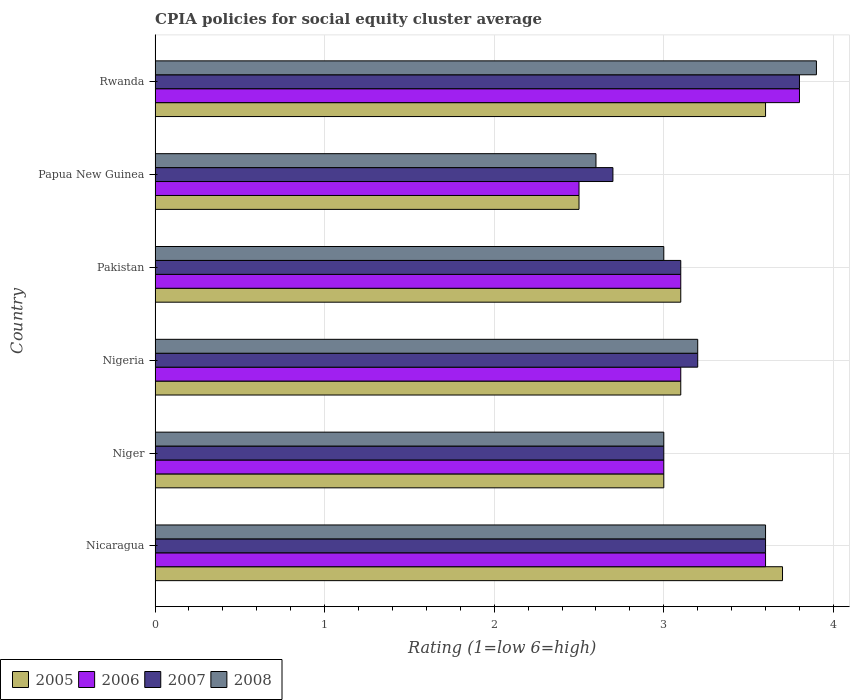How many groups of bars are there?
Your answer should be compact. 6. Are the number of bars on each tick of the Y-axis equal?
Give a very brief answer. Yes. What is the label of the 5th group of bars from the top?
Keep it short and to the point. Niger. Across all countries, what is the maximum CPIA rating in 2007?
Give a very brief answer. 3.8. In which country was the CPIA rating in 2007 maximum?
Keep it short and to the point. Rwanda. In which country was the CPIA rating in 2008 minimum?
Offer a very short reply. Papua New Guinea. What is the total CPIA rating in 2005 in the graph?
Provide a succinct answer. 19. What is the difference between the CPIA rating in 2008 in Niger and that in Pakistan?
Provide a succinct answer. 0. What is the difference between the CPIA rating in 2008 in Nigeria and the CPIA rating in 2007 in Nicaragua?
Your answer should be compact. -0.4. What is the average CPIA rating in 2006 per country?
Your response must be concise. 3.18. What is the difference between the CPIA rating in 2006 and CPIA rating in 2008 in Nicaragua?
Provide a short and direct response. 0. In how many countries, is the CPIA rating in 2008 greater than 2.2 ?
Your answer should be compact. 6. Is the difference between the CPIA rating in 2006 in Niger and Pakistan greater than the difference between the CPIA rating in 2008 in Niger and Pakistan?
Your answer should be compact. No. What is the difference between the highest and the second highest CPIA rating in 2005?
Keep it short and to the point. 0.1. What is the difference between the highest and the lowest CPIA rating in 2006?
Provide a succinct answer. 1.3. Are all the bars in the graph horizontal?
Keep it short and to the point. Yes. What is the difference between two consecutive major ticks on the X-axis?
Offer a very short reply. 1. Are the values on the major ticks of X-axis written in scientific E-notation?
Give a very brief answer. No. Does the graph contain grids?
Ensure brevity in your answer.  Yes. Where does the legend appear in the graph?
Your answer should be compact. Bottom left. How many legend labels are there?
Keep it short and to the point. 4. What is the title of the graph?
Your answer should be compact. CPIA policies for social equity cluster average. What is the label or title of the X-axis?
Your response must be concise. Rating (1=low 6=high). What is the Rating (1=low 6=high) in 2006 in Nicaragua?
Provide a succinct answer. 3.6. What is the Rating (1=low 6=high) in 2007 in Nicaragua?
Provide a succinct answer. 3.6. What is the Rating (1=low 6=high) of 2006 in Nigeria?
Keep it short and to the point. 3.1. What is the Rating (1=low 6=high) in 2008 in Nigeria?
Your answer should be very brief. 3.2. What is the Rating (1=low 6=high) of 2005 in Pakistan?
Provide a short and direct response. 3.1. What is the Rating (1=low 6=high) in 2008 in Pakistan?
Your answer should be compact. 3. What is the Rating (1=low 6=high) of 2006 in Papua New Guinea?
Your answer should be very brief. 2.5. What is the Rating (1=low 6=high) of 2006 in Rwanda?
Offer a very short reply. 3.8. Across all countries, what is the maximum Rating (1=low 6=high) in 2005?
Your response must be concise. 3.7. Across all countries, what is the minimum Rating (1=low 6=high) in 2006?
Your answer should be compact. 2.5. Across all countries, what is the minimum Rating (1=low 6=high) in 2008?
Offer a terse response. 2.6. What is the total Rating (1=low 6=high) in 2007 in the graph?
Your answer should be very brief. 19.4. What is the total Rating (1=low 6=high) of 2008 in the graph?
Provide a succinct answer. 19.3. What is the difference between the Rating (1=low 6=high) of 2007 in Nicaragua and that in Niger?
Offer a very short reply. 0.6. What is the difference between the Rating (1=low 6=high) of 2008 in Nicaragua and that in Niger?
Provide a succinct answer. 0.6. What is the difference between the Rating (1=low 6=high) of 2005 in Nicaragua and that in Nigeria?
Your answer should be very brief. 0.6. What is the difference between the Rating (1=low 6=high) of 2006 in Nicaragua and that in Nigeria?
Keep it short and to the point. 0.5. What is the difference between the Rating (1=low 6=high) in 2007 in Nicaragua and that in Nigeria?
Provide a succinct answer. 0.4. What is the difference between the Rating (1=low 6=high) in 2005 in Nicaragua and that in Pakistan?
Give a very brief answer. 0.6. What is the difference between the Rating (1=low 6=high) of 2007 in Nicaragua and that in Papua New Guinea?
Your answer should be very brief. 0.9. What is the difference between the Rating (1=low 6=high) in 2008 in Nicaragua and that in Papua New Guinea?
Your answer should be very brief. 1. What is the difference between the Rating (1=low 6=high) of 2006 in Nicaragua and that in Rwanda?
Your response must be concise. -0.2. What is the difference between the Rating (1=low 6=high) in 2005 in Niger and that in Nigeria?
Ensure brevity in your answer.  -0.1. What is the difference between the Rating (1=low 6=high) of 2006 in Niger and that in Nigeria?
Keep it short and to the point. -0.1. What is the difference between the Rating (1=low 6=high) in 2007 in Niger and that in Nigeria?
Provide a short and direct response. -0.2. What is the difference between the Rating (1=low 6=high) in 2008 in Niger and that in Nigeria?
Provide a succinct answer. -0.2. What is the difference between the Rating (1=low 6=high) in 2005 in Niger and that in Pakistan?
Ensure brevity in your answer.  -0.1. What is the difference between the Rating (1=low 6=high) of 2006 in Niger and that in Pakistan?
Offer a very short reply. -0.1. What is the difference between the Rating (1=low 6=high) of 2007 in Niger and that in Pakistan?
Provide a succinct answer. -0.1. What is the difference between the Rating (1=low 6=high) of 2005 in Niger and that in Papua New Guinea?
Make the answer very short. 0.5. What is the difference between the Rating (1=low 6=high) in 2005 in Niger and that in Rwanda?
Ensure brevity in your answer.  -0.6. What is the difference between the Rating (1=low 6=high) of 2006 in Niger and that in Rwanda?
Your answer should be compact. -0.8. What is the difference between the Rating (1=low 6=high) of 2008 in Niger and that in Rwanda?
Provide a short and direct response. -0.9. What is the difference between the Rating (1=low 6=high) in 2006 in Nigeria and that in Pakistan?
Ensure brevity in your answer.  0. What is the difference between the Rating (1=low 6=high) in 2007 in Nigeria and that in Papua New Guinea?
Ensure brevity in your answer.  0.5. What is the difference between the Rating (1=low 6=high) in 2007 in Nigeria and that in Rwanda?
Give a very brief answer. -0.6. What is the difference between the Rating (1=low 6=high) of 2006 in Pakistan and that in Papua New Guinea?
Your answer should be very brief. 0.6. What is the difference between the Rating (1=low 6=high) in 2007 in Pakistan and that in Papua New Guinea?
Give a very brief answer. 0.4. What is the difference between the Rating (1=low 6=high) of 2008 in Pakistan and that in Papua New Guinea?
Offer a very short reply. 0.4. What is the difference between the Rating (1=low 6=high) in 2005 in Pakistan and that in Rwanda?
Offer a terse response. -0.5. What is the difference between the Rating (1=low 6=high) of 2007 in Pakistan and that in Rwanda?
Your answer should be compact. -0.7. What is the difference between the Rating (1=low 6=high) in 2008 in Pakistan and that in Rwanda?
Give a very brief answer. -0.9. What is the difference between the Rating (1=low 6=high) in 2007 in Papua New Guinea and that in Rwanda?
Your response must be concise. -1.1. What is the difference between the Rating (1=low 6=high) of 2008 in Papua New Guinea and that in Rwanda?
Your response must be concise. -1.3. What is the difference between the Rating (1=low 6=high) of 2005 in Nicaragua and the Rating (1=low 6=high) of 2007 in Niger?
Offer a very short reply. 0.7. What is the difference between the Rating (1=low 6=high) of 2007 in Nicaragua and the Rating (1=low 6=high) of 2008 in Niger?
Provide a succinct answer. 0.6. What is the difference between the Rating (1=low 6=high) of 2005 in Nicaragua and the Rating (1=low 6=high) of 2006 in Nigeria?
Keep it short and to the point. 0.6. What is the difference between the Rating (1=low 6=high) in 2005 in Nicaragua and the Rating (1=low 6=high) in 2008 in Nigeria?
Give a very brief answer. 0.5. What is the difference between the Rating (1=low 6=high) of 2006 in Nicaragua and the Rating (1=low 6=high) of 2008 in Nigeria?
Offer a very short reply. 0.4. What is the difference between the Rating (1=low 6=high) of 2007 in Nicaragua and the Rating (1=low 6=high) of 2008 in Pakistan?
Provide a succinct answer. 0.6. What is the difference between the Rating (1=low 6=high) in 2005 in Nicaragua and the Rating (1=low 6=high) in 2007 in Papua New Guinea?
Your answer should be compact. 1. What is the difference between the Rating (1=low 6=high) in 2006 in Nicaragua and the Rating (1=low 6=high) in 2007 in Papua New Guinea?
Offer a very short reply. 0.9. What is the difference between the Rating (1=low 6=high) of 2006 in Nicaragua and the Rating (1=low 6=high) of 2008 in Papua New Guinea?
Provide a succinct answer. 1. What is the difference between the Rating (1=low 6=high) of 2007 in Nicaragua and the Rating (1=low 6=high) of 2008 in Papua New Guinea?
Provide a short and direct response. 1. What is the difference between the Rating (1=low 6=high) in 2006 in Nicaragua and the Rating (1=low 6=high) in 2007 in Rwanda?
Your answer should be very brief. -0.2. What is the difference between the Rating (1=low 6=high) of 2005 in Niger and the Rating (1=low 6=high) of 2006 in Nigeria?
Ensure brevity in your answer.  -0.1. What is the difference between the Rating (1=low 6=high) in 2005 in Niger and the Rating (1=low 6=high) in 2007 in Nigeria?
Make the answer very short. -0.2. What is the difference between the Rating (1=low 6=high) of 2005 in Niger and the Rating (1=low 6=high) of 2008 in Nigeria?
Give a very brief answer. -0.2. What is the difference between the Rating (1=low 6=high) in 2007 in Niger and the Rating (1=low 6=high) in 2008 in Nigeria?
Your answer should be compact. -0.2. What is the difference between the Rating (1=low 6=high) in 2006 in Niger and the Rating (1=low 6=high) in 2007 in Pakistan?
Offer a very short reply. -0.1. What is the difference between the Rating (1=low 6=high) in 2005 in Niger and the Rating (1=low 6=high) in 2006 in Papua New Guinea?
Your answer should be compact. 0.5. What is the difference between the Rating (1=low 6=high) in 2006 in Niger and the Rating (1=low 6=high) in 2007 in Papua New Guinea?
Your answer should be compact. 0.3. What is the difference between the Rating (1=low 6=high) in 2007 in Niger and the Rating (1=low 6=high) in 2008 in Papua New Guinea?
Provide a short and direct response. 0.4. What is the difference between the Rating (1=low 6=high) of 2005 in Niger and the Rating (1=low 6=high) of 2006 in Rwanda?
Your answer should be very brief. -0.8. What is the difference between the Rating (1=low 6=high) in 2005 in Niger and the Rating (1=low 6=high) in 2007 in Rwanda?
Offer a terse response. -0.8. What is the difference between the Rating (1=low 6=high) of 2005 in Niger and the Rating (1=low 6=high) of 2008 in Rwanda?
Provide a short and direct response. -0.9. What is the difference between the Rating (1=low 6=high) of 2007 in Niger and the Rating (1=low 6=high) of 2008 in Rwanda?
Your answer should be very brief. -0.9. What is the difference between the Rating (1=low 6=high) in 2007 in Nigeria and the Rating (1=low 6=high) in 2008 in Pakistan?
Ensure brevity in your answer.  0.2. What is the difference between the Rating (1=low 6=high) of 2005 in Nigeria and the Rating (1=low 6=high) of 2006 in Papua New Guinea?
Offer a terse response. 0.6. What is the difference between the Rating (1=low 6=high) of 2006 in Nigeria and the Rating (1=low 6=high) of 2008 in Papua New Guinea?
Your answer should be compact. 0.5. What is the difference between the Rating (1=low 6=high) of 2005 in Nigeria and the Rating (1=low 6=high) of 2006 in Rwanda?
Give a very brief answer. -0.7. What is the difference between the Rating (1=low 6=high) of 2005 in Nigeria and the Rating (1=low 6=high) of 2007 in Rwanda?
Keep it short and to the point. -0.7. What is the difference between the Rating (1=low 6=high) of 2005 in Nigeria and the Rating (1=low 6=high) of 2008 in Rwanda?
Your answer should be very brief. -0.8. What is the difference between the Rating (1=low 6=high) of 2005 in Pakistan and the Rating (1=low 6=high) of 2006 in Papua New Guinea?
Keep it short and to the point. 0.6. What is the difference between the Rating (1=low 6=high) of 2006 in Pakistan and the Rating (1=low 6=high) of 2007 in Papua New Guinea?
Provide a succinct answer. 0.4. What is the difference between the Rating (1=low 6=high) in 2006 in Pakistan and the Rating (1=low 6=high) in 2008 in Papua New Guinea?
Make the answer very short. 0.5. What is the difference between the Rating (1=low 6=high) of 2007 in Pakistan and the Rating (1=low 6=high) of 2008 in Papua New Guinea?
Provide a succinct answer. 0.5. What is the difference between the Rating (1=low 6=high) in 2005 in Pakistan and the Rating (1=low 6=high) in 2006 in Rwanda?
Ensure brevity in your answer.  -0.7. What is the difference between the Rating (1=low 6=high) of 2007 in Pakistan and the Rating (1=low 6=high) of 2008 in Rwanda?
Make the answer very short. -0.8. What is the difference between the Rating (1=low 6=high) in 2006 in Papua New Guinea and the Rating (1=low 6=high) in 2008 in Rwanda?
Keep it short and to the point. -1.4. What is the average Rating (1=low 6=high) of 2005 per country?
Ensure brevity in your answer.  3.17. What is the average Rating (1=low 6=high) in 2006 per country?
Your response must be concise. 3.18. What is the average Rating (1=low 6=high) of 2007 per country?
Keep it short and to the point. 3.23. What is the average Rating (1=low 6=high) in 2008 per country?
Your answer should be very brief. 3.22. What is the difference between the Rating (1=low 6=high) in 2005 and Rating (1=low 6=high) in 2007 in Nicaragua?
Your answer should be very brief. 0.1. What is the difference between the Rating (1=low 6=high) in 2005 and Rating (1=low 6=high) in 2008 in Nicaragua?
Ensure brevity in your answer.  0.1. What is the difference between the Rating (1=low 6=high) of 2006 and Rating (1=low 6=high) of 2007 in Nicaragua?
Offer a very short reply. 0. What is the difference between the Rating (1=low 6=high) of 2006 and Rating (1=low 6=high) of 2008 in Nicaragua?
Your answer should be very brief. 0. What is the difference between the Rating (1=low 6=high) of 2005 and Rating (1=low 6=high) of 2006 in Niger?
Provide a succinct answer. 0. What is the difference between the Rating (1=low 6=high) of 2005 and Rating (1=low 6=high) of 2007 in Niger?
Ensure brevity in your answer.  0. What is the difference between the Rating (1=low 6=high) in 2005 and Rating (1=low 6=high) in 2006 in Nigeria?
Give a very brief answer. 0. What is the difference between the Rating (1=low 6=high) in 2005 and Rating (1=low 6=high) in 2008 in Nigeria?
Keep it short and to the point. -0.1. What is the difference between the Rating (1=low 6=high) in 2006 and Rating (1=low 6=high) in 2007 in Nigeria?
Your answer should be very brief. -0.1. What is the difference between the Rating (1=low 6=high) in 2006 and Rating (1=low 6=high) in 2008 in Nigeria?
Your answer should be very brief. -0.1. What is the difference between the Rating (1=low 6=high) in 2007 and Rating (1=low 6=high) in 2008 in Nigeria?
Offer a very short reply. 0. What is the difference between the Rating (1=low 6=high) in 2005 and Rating (1=low 6=high) in 2006 in Pakistan?
Ensure brevity in your answer.  0. What is the difference between the Rating (1=low 6=high) of 2005 and Rating (1=low 6=high) of 2008 in Pakistan?
Your answer should be compact. 0.1. What is the difference between the Rating (1=low 6=high) in 2006 and Rating (1=low 6=high) in 2008 in Pakistan?
Keep it short and to the point. 0.1. What is the difference between the Rating (1=low 6=high) in 2007 and Rating (1=low 6=high) in 2008 in Papua New Guinea?
Your answer should be very brief. 0.1. What is the difference between the Rating (1=low 6=high) of 2005 and Rating (1=low 6=high) of 2007 in Rwanda?
Provide a short and direct response. -0.2. What is the difference between the Rating (1=low 6=high) in 2006 and Rating (1=low 6=high) in 2007 in Rwanda?
Offer a terse response. 0. What is the difference between the Rating (1=low 6=high) in 2006 and Rating (1=low 6=high) in 2008 in Rwanda?
Your answer should be very brief. -0.1. What is the difference between the Rating (1=low 6=high) in 2007 and Rating (1=low 6=high) in 2008 in Rwanda?
Offer a very short reply. -0.1. What is the ratio of the Rating (1=low 6=high) of 2005 in Nicaragua to that in Niger?
Ensure brevity in your answer.  1.23. What is the ratio of the Rating (1=low 6=high) of 2007 in Nicaragua to that in Niger?
Give a very brief answer. 1.2. What is the ratio of the Rating (1=low 6=high) in 2008 in Nicaragua to that in Niger?
Offer a very short reply. 1.2. What is the ratio of the Rating (1=low 6=high) of 2005 in Nicaragua to that in Nigeria?
Your answer should be very brief. 1.19. What is the ratio of the Rating (1=low 6=high) of 2006 in Nicaragua to that in Nigeria?
Your answer should be compact. 1.16. What is the ratio of the Rating (1=low 6=high) in 2005 in Nicaragua to that in Pakistan?
Ensure brevity in your answer.  1.19. What is the ratio of the Rating (1=low 6=high) in 2006 in Nicaragua to that in Pakistan?
Your answer should be very brief. 1.16. What is the ratio of the Rating (1=low 6=high) of 2007 in Nicaragua to that in Pakistan?
Provide a succinct answer. 1.16. What is the ratio of the Rating (1=low 6=high) in 2008 in Nicaragua to that in Pakistan?
Keep it short and to the point. 1.2. What is the ratio of the Rating (1=low 6=high) in 2005 in Nicaragua to that in Papua New Guinea?
Keep it short and to the point. 1.48. What is the ratio of the Rating (1=low 6=high) of 2006 in Nicaragua to that in Papua New Guinea?
Keep it short and to the point. 1.44. What is the ratio of the Rating (1=low 6=high) in 2008 in Nicaragua to that in Papua New Guinea?
Ensure brevity in your answer.  1.38. What is the ratio of the Rating (1=low 6=high) of 2005 in Nicaragua to that in Rwanda?
Keep it short and to the point. 1.03. What is the ratio of the Rating (1=low 6=high) of 2006 in Nicaragua to that in Rwanda?
Make the answer very short. 0.95. What is the ratio of the Rating (1=low 6=high) in 2007 in Nicaragua to that in Rwanda?
Provide a succinct answer. 0.95. What is the ratio of the Rating (1=low 6=high) of 2008 in Nicaragua to that in Rwanda?
Ensure brevity in your answer.  0.92. What is the ratio of the Rating (1=low 6=high) of 2005 in Niger to that in Nigeria?
Provide a succinct answer. 0.97. What is the ratio of the Rating (1=low 6=high) in 2007 in Niger to that in Nigeria?
Your response must be concise. 0.94. What is the ratio of the Rating (1=low 6=high) of 2008 in Niger to that in Nigeria?
Provide a succinct answer. 0.94. What is the ratio of the Rating (1=low 6=high) in 2007 in Niger to that in Pakistan?
Your response must be concise. 0.97. What is the ratio of the Rating (1=low 6=high) in 2008 in Niger to that in Pakistan?
Keep it short and to the point. 1. What is the ratio of the Rating (1=low 6=high) in 2005 in Niger to that in Papua New Guinea?
Your answer should be compact. 1.2. What is the ratio of the Rating (1=low 6=high) in 2006 in Niger to that in Papua New Guinea?
Keep it short and to the point. 1.2. What is the ratio of the Rating (1=low 6=high) in 2008 in Niger to that in Papua New Guinea?
Offer a terse response. 1.15. What is the ratio of the Rating (1=low 6=high) in 2006 in Niger to that in Rwanda?
Make the answer very short. 0.79. What is the ratio of the Rating (1=low 6=high) of 2007 in Niger to that in Rwanda?
Provide a succinct answer. 0.79. What is the ratio of the Rating (1=low 6=high) of 2008 in Niger to that in Rwanda?
Make the answer very short. 0.77. What is the ratio of the Rating (1=low 6=high) in 2005 in Nigeria to that in Pakistan?
Your answer should be very brief. 1. What is the ratio of the Rating (1=low 6=high) in 2007 in Nigeria to that in Pakistan?
Your answer should be compact. 1.03. What is the ratio of the Rating (1=low 6=high) of 2008 in Nigeria to that in Pakistan?
Ensure brevity in your answer.  1.07. What is the ratio of the Rating (1=low 6=high) in 2005 in Nigeria to that in Papua New Guinea?
Give a very brief answer. 1.24. What is the ratio of the Rating (1=low 6=high) of 2006 in Nigeria to that in Papua New Guinea?
Provide a succinct answer. 1.24. What is the ratio of the Rating (1=low 6=high) of 2007 in Nigeria to that in Papua New Guinea?
Keep it short and to the point. 1.19. What is the ratio of the Rating (1=low 6=high) of 2008 in Nigeria to that in Papua New Guinea?
Offer a very short reply. 1.23. What is the ratio of the Rating (1=low 6=high) of 2005 in Nigeria to that in Rwanda?
Offer a terse response. 0.86. What is the ratio of the Rating (1=low 6=high) in 2006 in Nigeria to that in Rwanda?
Provide a succinct answer. 0.82. What is the ratio of the Rating (1=low 6=high) of 2007 in Nigeria to that in Rwanda?
Provide a succinct answer. 0.84. What is the ratio of the Rating (1=low 6=high) in 2008 in Nigeria to that in Rwanda?
Your response must be concise. 0.82. What is the ratio of the Rating (1=low 6=high) in 2005 in Pakistan to that in Papua New Guinea?
Your answer should be very brief. 1.24. What is the ratio of the Rating (1=low 6=high) of 2006 in Pakistan to that in Papua New Guinea?
Give a very brief answer. 1.24. What is the ratio of the Rating (1=low 6=high) in 2007 in Pakistan to that in Papua New Guinea?
Your answer should be compact. 1.15. What is the ratio of the Rating (1=low 6=high) of 2008 in Pakistan to that in Papua New Guinea?
Your answer should be compact. 1.15. What is the ratio of the Rating (1=low 6=high) in 2005 in Pakistan to that in Rwanda?
Make the answer very short. 0.86. What is the ratio of the Rating (1=low 6=high) in 2006 in Pakistan to that in Rwanda?
Offer a very short reply. 0.82. What is the ratio of the Rating (1=low 6=high) in 2007 in Pakistan to that in Rwanda?
Give a very brief answer. 0.82. What is the ratio of the Rating (1=low 6=high) of 2008 in Pakistan to that in Rwanda?
Your response must be concise. 0.77. What is the ratio of the Rating (1=low 6=high) in 2005 in Papua New Guinea to that in Rwanda?
Give a very brief answer. 0.69. What is the ratio of the Rating (1=low 6=high) in 2006 in Papua New Guinea to that in Rwanda?
Your answer should be compact. 0.66. What is the ratio of the Rating (1=low 6=high) in 2007 in Papua New Guinea to that in Rwanda?
Provide a short and direct response. 0.71. What is the ratio of the Rating (1=low 6=high) of 2008 in Papua New Guinea to that in Rwanda?
Provide a succinct answer. 0.67. What is the difference between the highest and the second highest Rating (1=low 6=high) of 2005?
Offer a terse response. 0.1. What is the difference between the highest and the second highest Rating (1=low 6=high) of 2008?
Keep it short and to the point. 0.3. What is the difference between the highest and the lowest Rating (1=low 6=high) of 2005?
Keep it short and to the point. 1.2. 